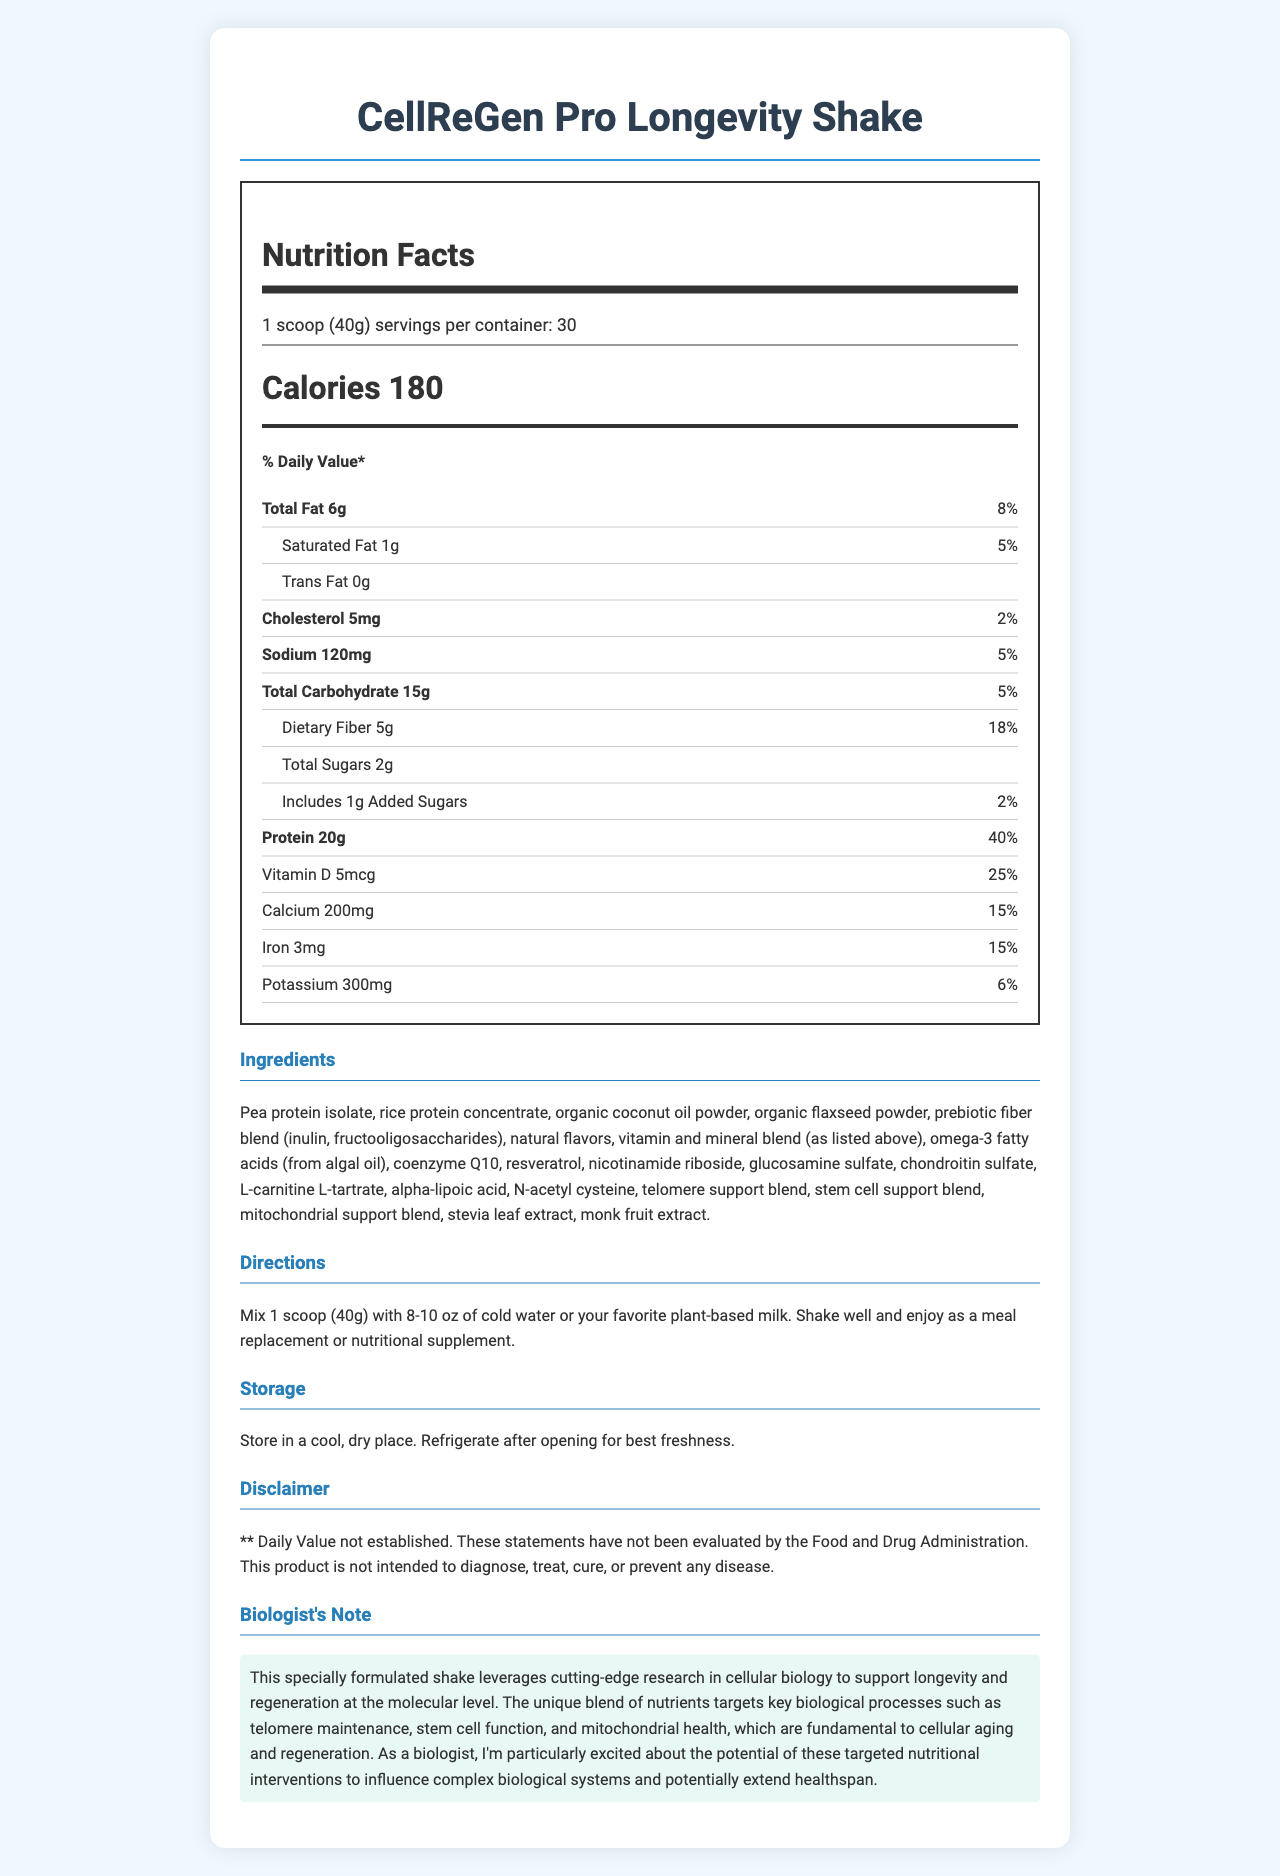what is the serving size for CellReGen Pro Longevity Shake? The serving size is specified at the beginning of the Nutrition Facts.
Answer: 1 scoop (40g) what are the total calories per serving? The total calories per serving are listed prominently under the serving information.
Answer: 180 calories how much protein does each serving contain? The protein content per serving is displayed in the Nutrition Facts, showing it contains 20g.
Answer: 20g what percentage of the daily value of dietary fiber is provided by one serving? The daily value of dietary fiber provided by one serving is shown as 18%.
Answer: 18% how many servings are in each container? The number of servings per container is specified right next to the serving size.
Answer: 30 servings which of the following vitamins has the highest daily value percentage per serving? A. Vitamin D B. Vitamin A C. Vitamin C Vitamin C has the highest daily value percentage at 100%, whereas Vitamin D is 25% and Vitamin A is 50%.
Answer: C the product contains which essential mineral at 100% daily value? A. Magnesium B. Calcium C. Zinc Zinc is listed with 100% daily value, while Magnesium is 24% and Calcium is 15%.
Answer: C does the product contain any allergens? The allergen information indicates that the product contains coconut.
Answer: Yes is the amount of coenzyme Q10 established for daily value? The document states that the daily value for coenzyme Q10 has not been established, marked by "**".
Answer: No what support blends are included in the product? The product includes a telomere support blend, stem cell support blend, and mitochondrial support blend, as detailed in the document.
Answer: Telomere support blend, stem cell support blend, mitochondrial support blend summarize the main idea of the document. The document encompasses comprehensive nutritional information and key biological functional aspects of the longevity shake, highlighting its designed purpose to support cellular regeneration and longevity through specific nutritional content and blends.
Answer: The document provides detailed nutritional information for the "CellReGen Pro Longevity Shake," a meal replacement shake designed to support cellular regeneration and longevity. It includes serving size, calorie content, percentage daily values of various nutrients, detailed ingredient lists, and special blends targeting biological processes such as telomere maintenance, stem cell function, and mitochondrial health. Additionally, there is allergen information, directions for use, storage instructions, and a disclaimer. how do you prepare the CellReGen Pro Longevity Shake? The preparation directions specify mixing 1 scoop (40g) with 8-10 oz of cold water or plant-based milk.
Answer: Mix 1 scoop (40g) with 8-10 oz of cold water or your favorite plant-based milk. what ingredients are in the Telomere support blend? The Telomere support blend consists of Astragalus root extract and Centella asiatica extract as specified.
Answer: Astragalus root extract, Centella asiatica extract can the daily value percentage for omega-3 fatty acids be determined from the document? The document indicates that the daily value for omega-3 fatty acids has not been established, marked by "**".
Answer: No what is the potential benefit of the CellReGen Pro Longevity Shake according to the Biologist's Note? The Biologist's Note suggests that the shake is formulated to support longevity and molecular-level regeneration through targeted nutritional interventions.
Answer: To support longevity and regeneration at the molecular level 